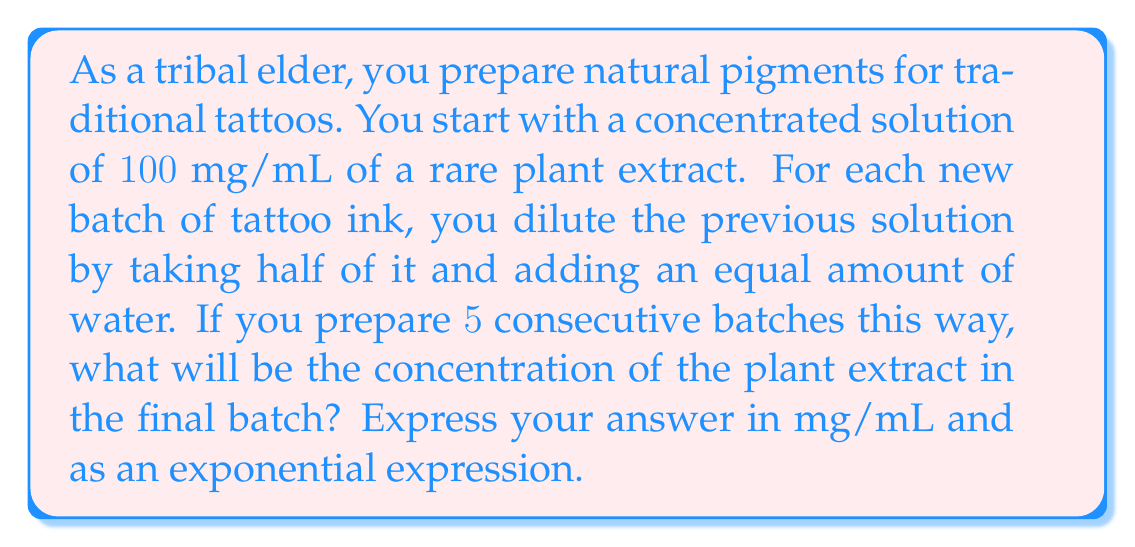Can you answer this question? Let's approach this step-by-step:

1) We start with a concentration of $100$ mg/mL.

2) Each dilution reduces the concentration by half:
   - After 1st dilution: $100 \cdot \frac{1}{2} = 50$ mg/mL
   - After 2nd dilution: $50 \cdot \frac{1}{2} = 25$ mg/mL
   - After 3rd dilution: $25 \cdot \frac{1}{2} = 12.5$ mg/mL
   - And so on...

3) We can express this mathematically as:
   $$ C_n = C_0 \cdot \left(\frac{1}{2}\right)^n $$
   Where $C_n$ is the concentration after $n$ dilutions, and $C_0$ is the initial concentration.

4) In this case, $C_0 = 100$ mg/mL and $n = 5$:
   $$ C_5 = 100 \cdot \left(\frac{1}{2}\right)^5 $$

5) To calculate this:
   $$ C_5 = 100 \cdot \frac{1}{32} = 3.125 \text{ mg/mL} $$

Thus, the final concentration can be expressed as $100 \cdot \left(\frac{1}{2}\right)^5$ mg/mL or $3.125$ mg/mL.
Answer: $100 \cdot \left(\frac{1}{2}\right)^5$ mg/mL or $3.125$ mg/mL 